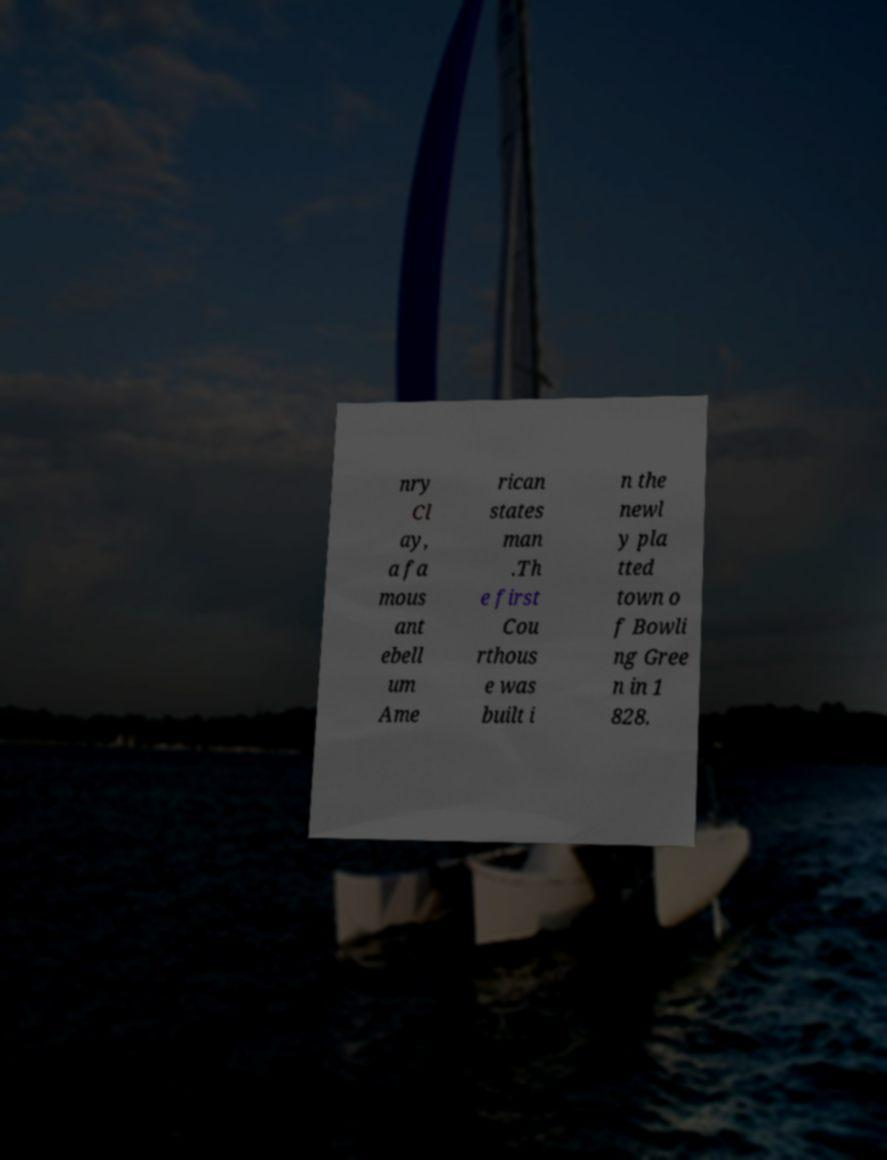What messages or text are displayed in this image? I need them in a readable, typed format. nry Cl ay, a fa mous ant ebell um Ame rican states man .Th e first Cou rthous e was built i n the newl y pla tted town o f Bowli ng Gree n in 1 828. 